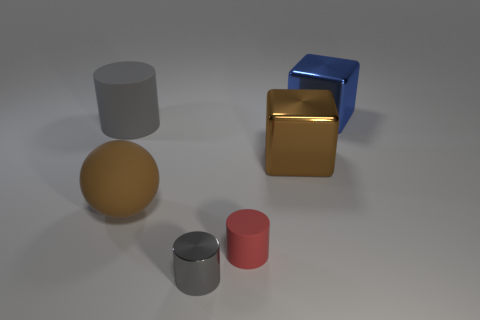Is the brown matte ball the same size as the gray shiny cylinder?
Provide a succinct answer. No. Is there anything else that is the same color as the ball?
Your answer should be compact. Yes. There is a gray object in front of the large gray matte cylinder; does it have the same shape as the large rubber thing to the left of the large brown ball?
Your answer should be compact. Yes. What number of cylinders are tiny gray things or red matte objects?
Provide a short and direct response. 2. How many large green metal cubes are there?
Your response must be concise. 0. Do the big blue metal thing and the gray thing that is behind the tiny gray metallic cylinder have the same shape?
Your answer should be compact. No. What is the size of the cube that is the same color as the ball?
Offer a very short reply. Large. How many things are large gray cylinders or tiny yellow things?
Your answer should be compact. 1. What shape is the shiny thing that is behind the metal block that is in front of the big blue block?
Provide a short and direct response. Cube. There is a small thing that is behind the gray shiny object; does it have the same shape as the tiny gray metal thing?
Offer a terse response. Yes. 